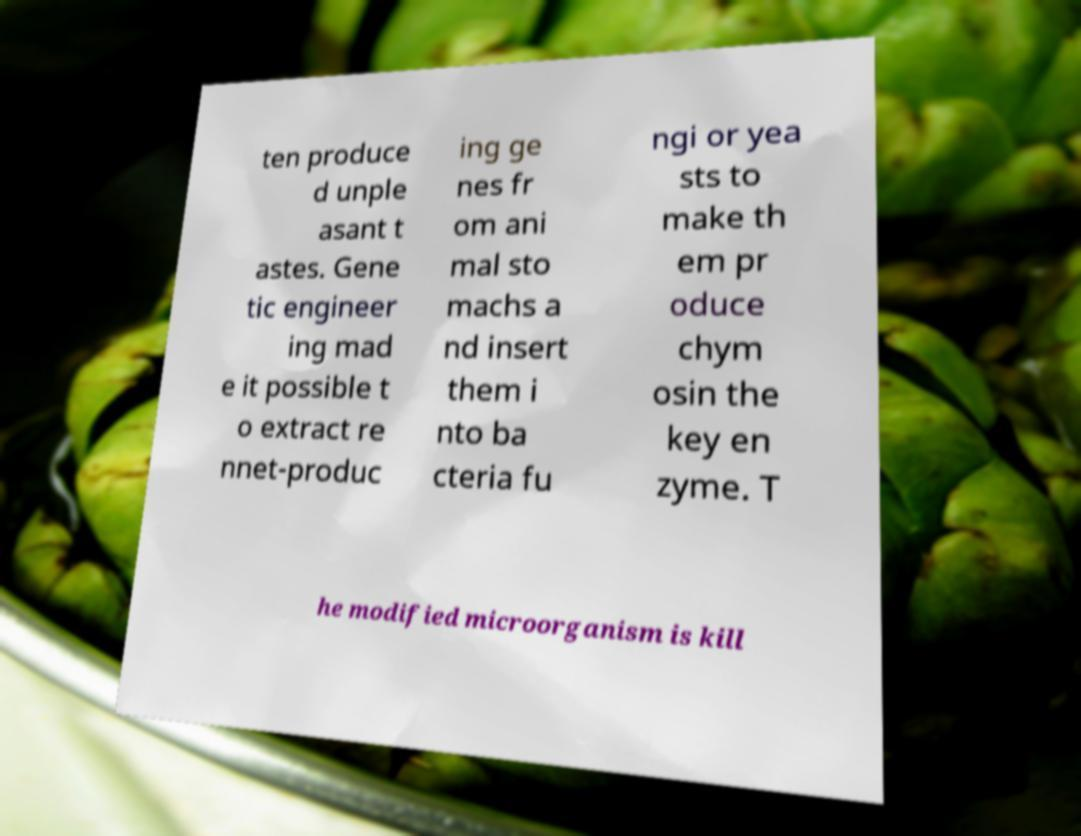Can you read and provide the text displayed in the image?This photo seems to have some interesting text. Can you extract and type it out for me? ten produce d unple asant t astes. Gene tic engineer ing mad e it possible t o extract re nnet-produc ing ge nes fr om ani mal sto machs a nd insert them i nto ba cteria fu ngi or yea sts to make th em pr oduce chym osin the key en zyme. T he modified microorganism is kill 